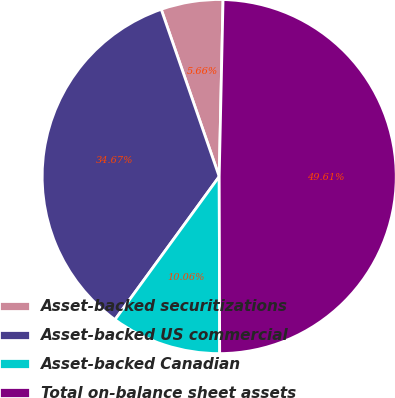Convert chart. <chart><loc_0><loc_0><loc_500><loc_500><pie_chart><fcel>Asset-backed securitizations<fcel>Asset-backed US commercial<fcel>Asset-backed Canadian<fcel>Total on-balance sheet assets<nl><fcel>5.66%<fcel>34.67%<fcel>10.06%<fcel>49.61%<nl></chart> 